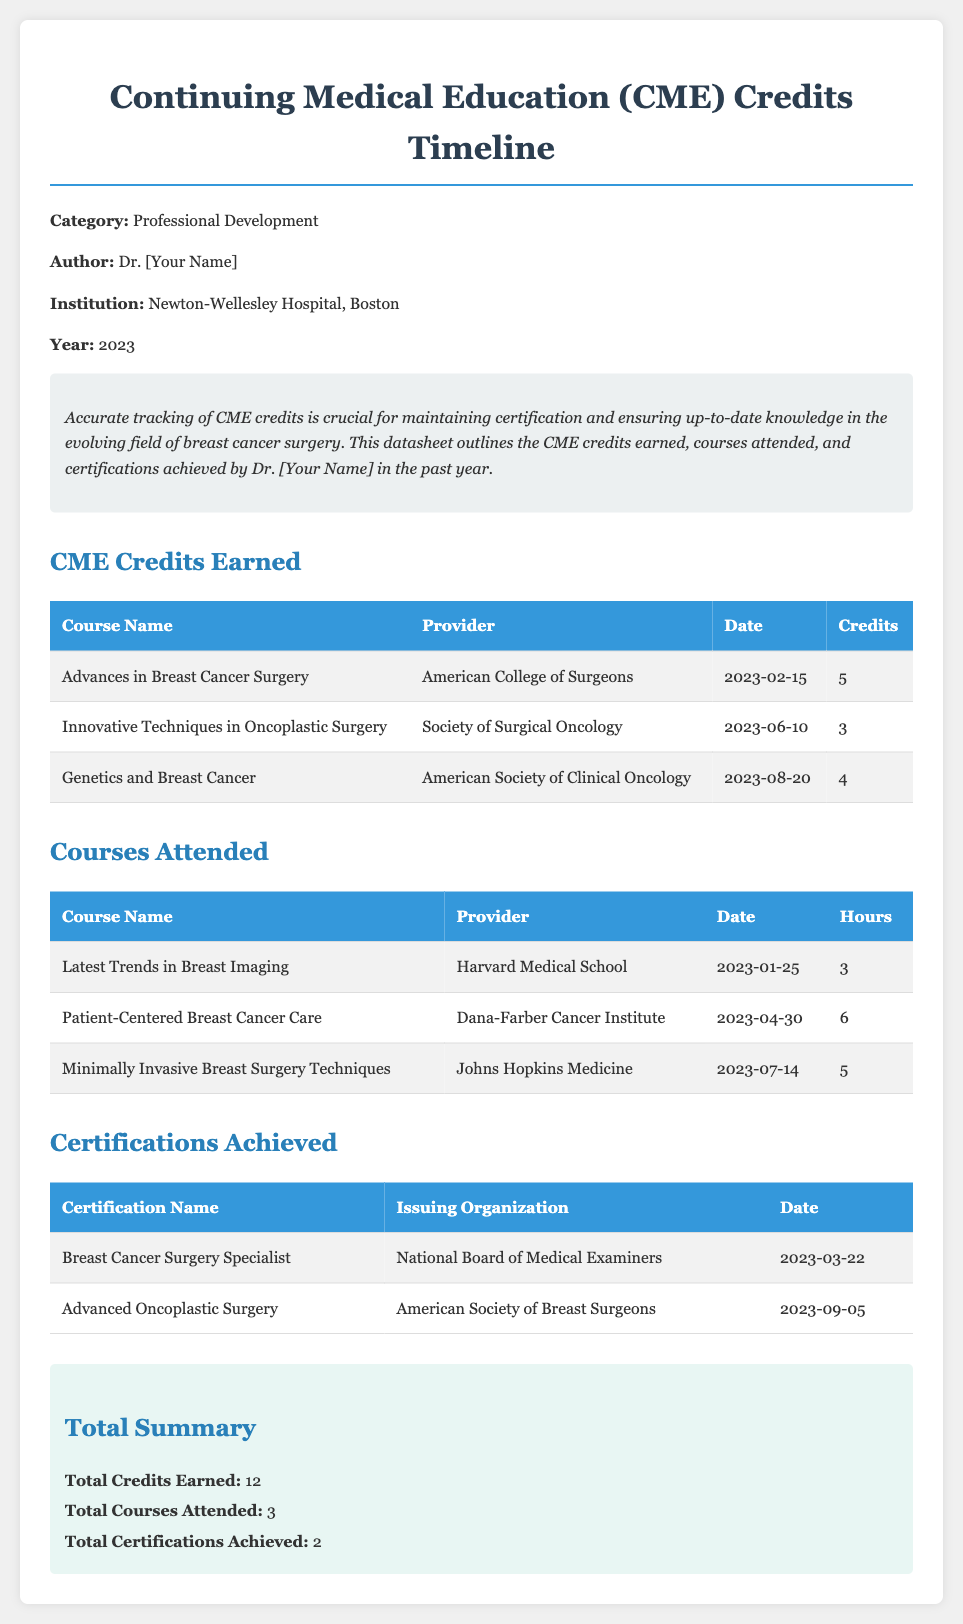what is the total number of CME credits earned? The total number of CME credits earned is provided in the summary section of the document, which states a total of 12 credits.
Answer: 12 who issued the certification for Breast Cancer Surgery Specialist? The issuing organization for the certification is specified in the certifications achieved table. It is the National Board of Medical Examiners.
Answer: National Board of Medical Examiners how many courses were attended in total? The total number of courses attended is indicated in the summary section, which notes 3 courses.
Answer: 3 what is the date of the course titled "Innovative Techniques in Oncoplastic Surgery"? The date for this specific course can be found in the CME Credits Earned table, which lists the date as June 10, 2023.
Answer: June 10, 2023 what is the name of the course offered by Harvard Medical School? The course name is listed in the Courses Attended table, which states it is "Latest Trends in Breast Imaging."
Answer: Latest Trends in Breast Imaging which certification was achieved on September 5, 2023? The date corresponds to the certification table, which shows the certification "Advanced Oncoplastic Surgery" was achieved on that date.
Answer: Advanced Oncoplastic Surgery how many total certifications were achieved? The total number of certifications is noted in the summary section as 2.
Answer: 2 what is the name of the course that earns 5 CME credits? This information can be found in the CME Credits Earned table, where "Advances in Breast Cancer Surgery" is listed with 5 credits.
Answer: Advances in Breast Cancer Surgery 